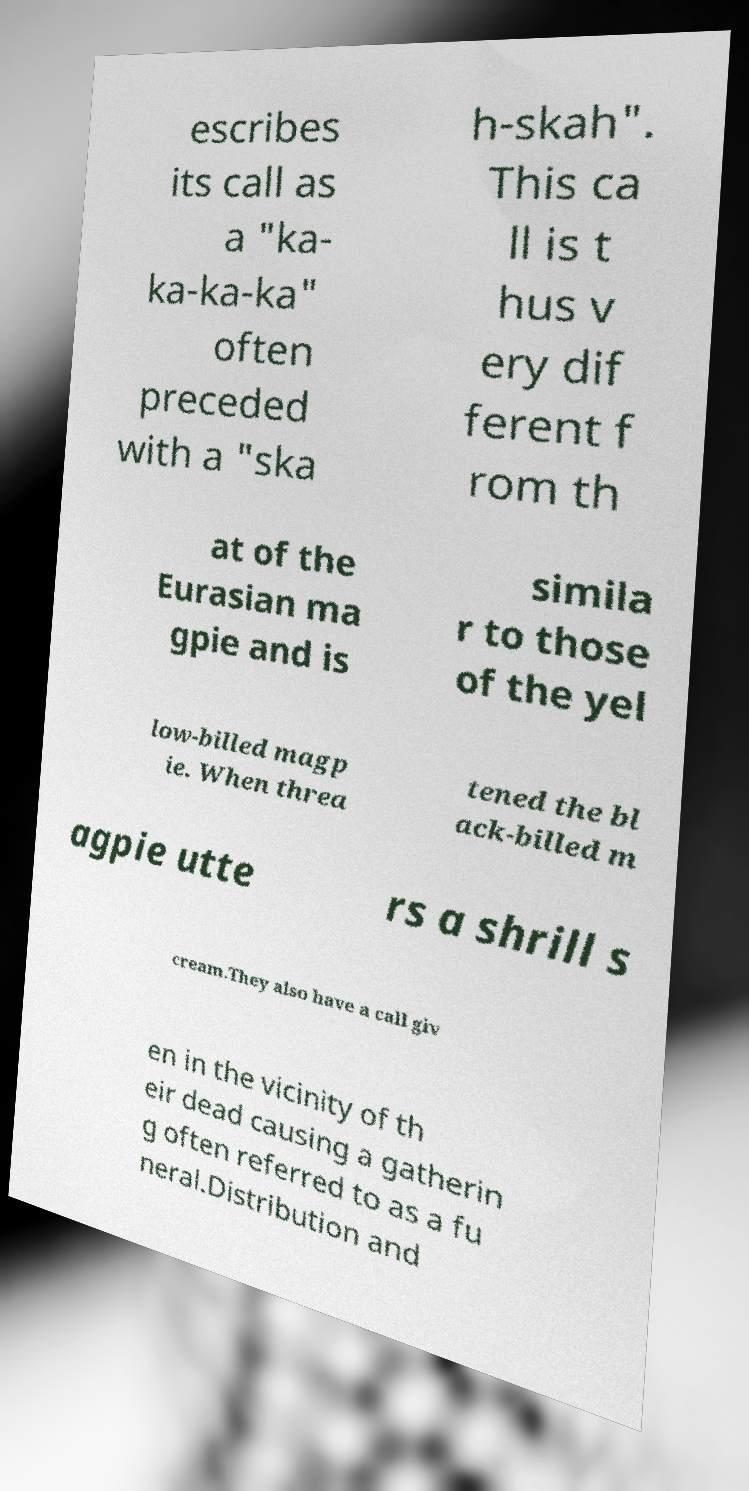I need the written content from this picture converted into text. Can you do that? escribes its call as a "ka- ka-ka-ka" often preceded with a "ska h-skah". This ca ll is t hus v ery dif ferent f rom th at of the Eurasian ma gpie and is simila r to those of the yel low-billed magp ie. When threa tened the bl ack-billed m agpie utte rs a shrill s cream.They also have a call giv en in the vicinity of th eir dead causing a gatherin g often referred to as a fu neral.Distribution and 